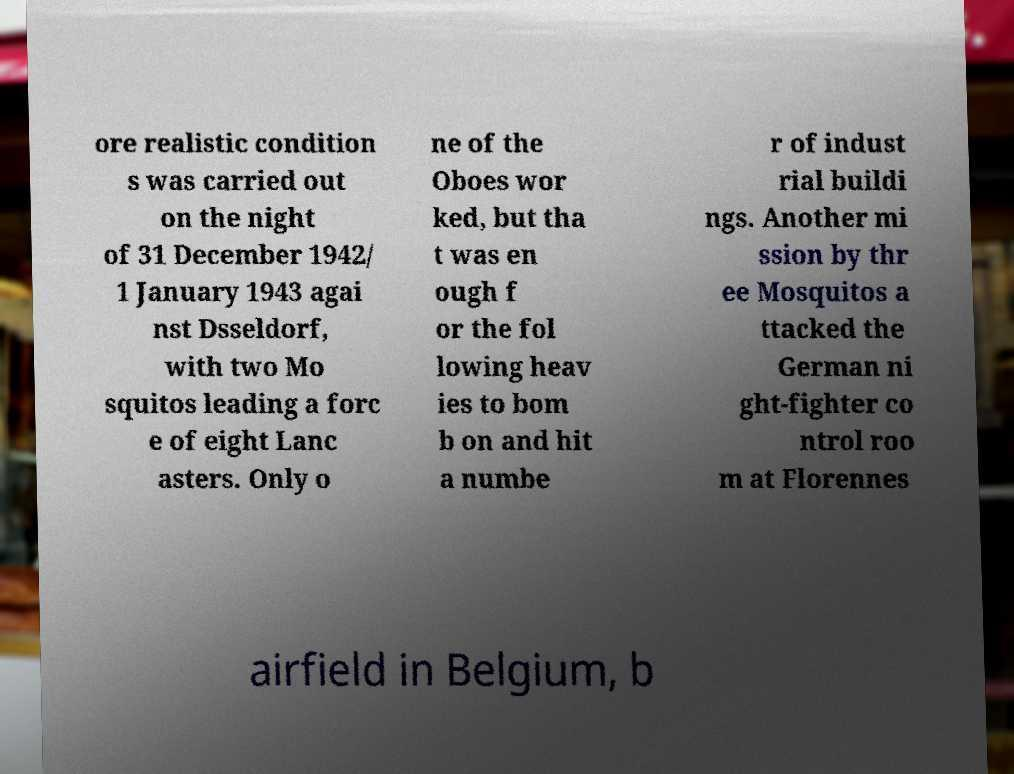Could you assist in decoding the text presented in this image and type it out clearly? ore realistic condition s was carried out on the night of 31 December 1942/ 1 January 1943 agai nst Dsseldorf, with two Mo squitos leading a forc e of eight Lanc asters. Only o ne of the Oboes wor ked, but tha t was en ough f or the fol lowing heav ies to bom b on and hit a numbe r of indust rial buildi ngs. Another mi ssion by thr ee Mosquitos a ttacked the German ni ght-fighter co ntrol roo m at Florennes airfield in Belgium, b 